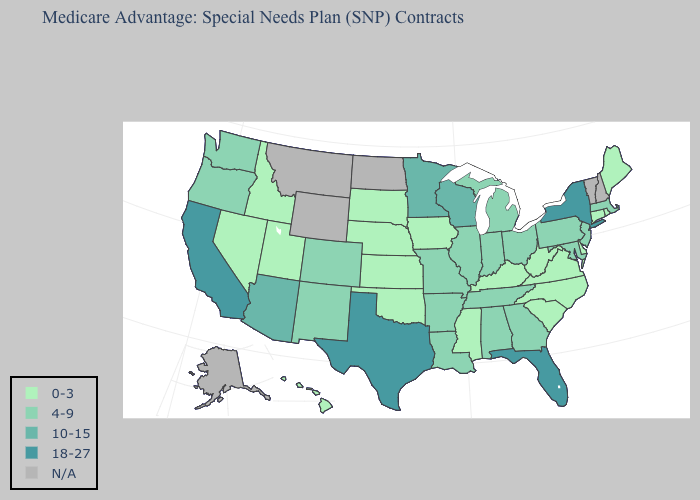Is the legend a continuous bar?
Write a very short answer. No. Does the map have missing data?
Keep it brief. Yes. Name the states that have a value in the range N/A?
Be succinct. Alaska, Montana, North Dakota, New Hampshire, Vermont, Wyoming. Name the states that have a value in the range N/A?
Short answer required. Alaska, Montana, North Dakota, New Hampshire, Vermont, Wyoming. Name the states that have a value in the range N/A?
Quick response, please. Alaska, Montana, North Dakota, New Hampshire, Vermont, Wyoming. Which states hav the highest value in the Northeast?
Short answer required. New York. What is the value of Michigan?
Short answer required. 4-9. Does Illinois have the highest value in the MidWest?
Write a very short answer. No. Which states have the lowest value in the USA?
Answer briefly. Connecticut, Delaware, Hawaii, Iowa, Idaho, Kansas, Kentucky, Maine, Mississippi, North Carolina, Nebraska, Nevada, Oklahoma, Rhode Island, South Carolina, South Dakota, Utah, Virginia, West Virginia. Among the states that border Ohio , does Kentucky have the lowest value?
Concise answer only. Yes. Among the states that border Connecticut , does Massachusetts have the highest value?
Answer briefly. No. What is the value of Louisiana?
Give a very brief answer. 4-9. 